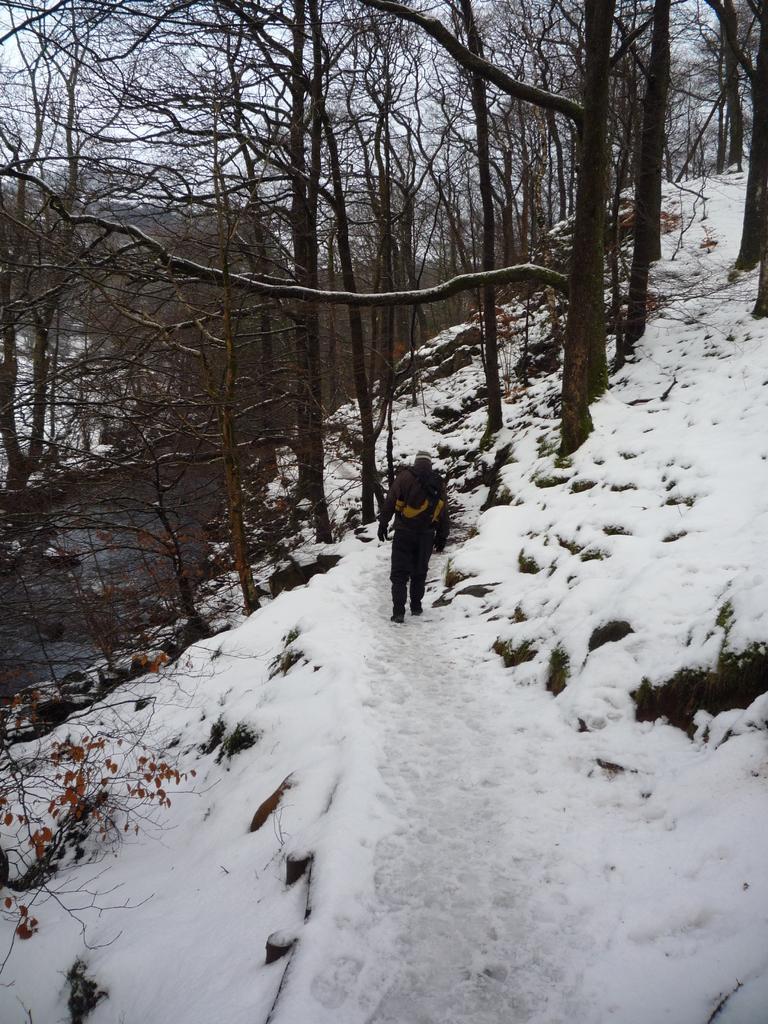How would you summarize this image in a sentence or two? This image is taken outdoors. In the background there are many trees with stems and branches. In the middle of the image a man is walking in the snow. At the bottom of the image there is a ground and it is totally covered with snow. On the left side of the image there is a tree with stems and leaves. 